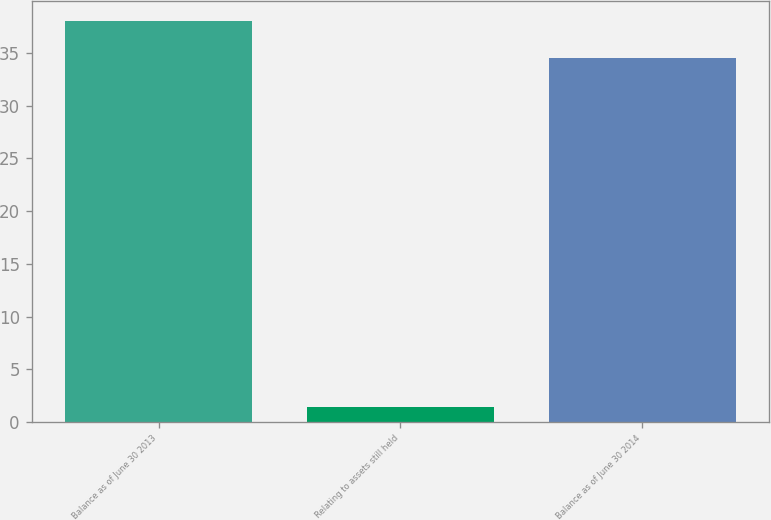Convert chart to OTSL. <chart><loc_0><loc_0><loc_500><loc_500><bar_chart><fcel>Balance as of June 30 2013<fcel>Relating to assets still held<fcel>Balance as of June 30 2014<nl><fcel>38.02<fcel>1.4<fcel>34.5<nl></chart> 